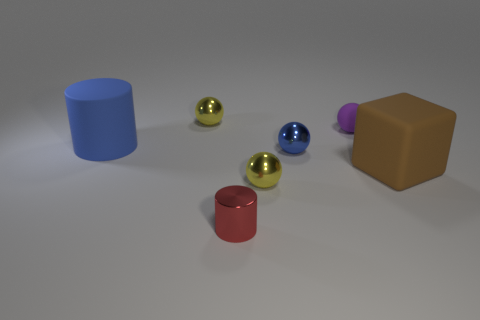What can you infer about the texture of the objects? The objects appear to have a smooth texture, with the spheres likely having a metallic finish evident by their reflections, while the blocks and cylinders have a matte finish that diffuses light uniformly. 